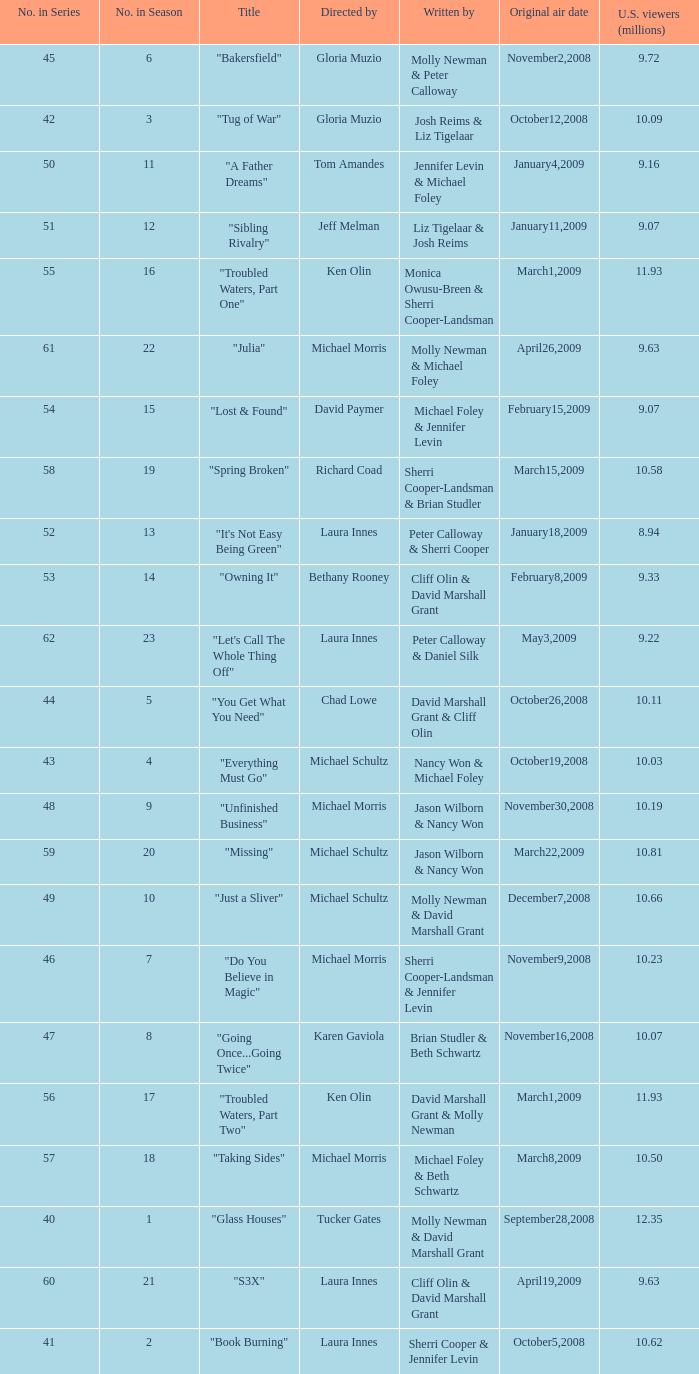When did the episode viewed by 10.50 millions of people in the US run for the first time? March8,2009. 